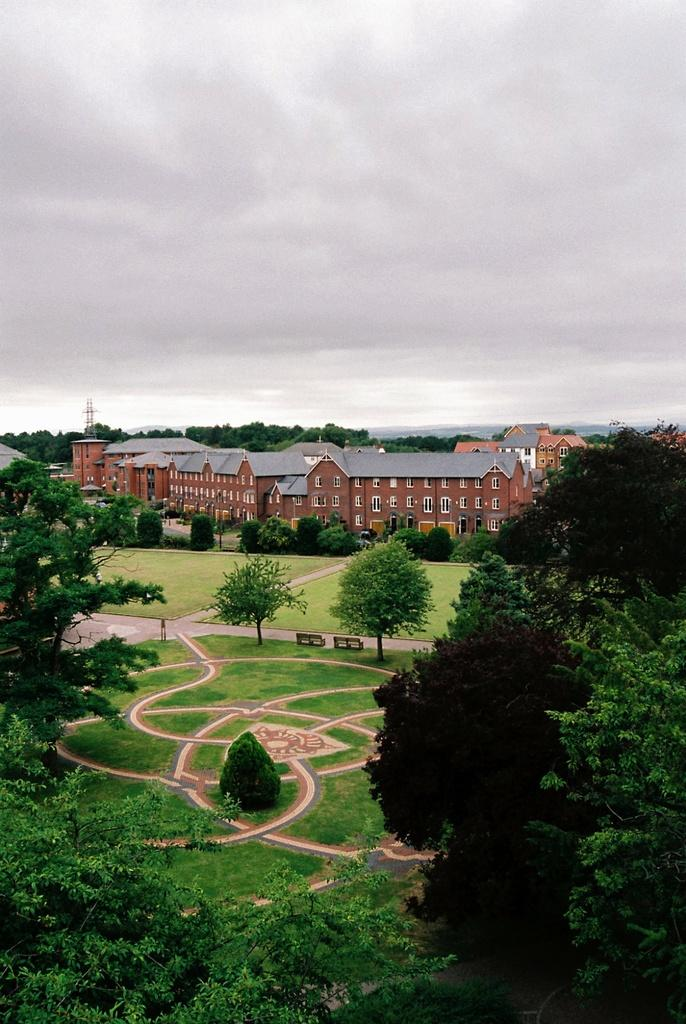What type of structure is visible in the image? There is a building in the image. What feature can be seen on the building? The building has windows. What type of vegetation is present in the image? There are trees in the image. What type of surface can be seen in the image? There is a path in the image. What type of seating is available in the image? There are benches in the image. What type of ground cover is present in the image? Grass is present in the image. What is the condition of the sky in the image? The sky is cloudy in the image. How many strings can be seen attached to the trees in the image? There are no strings visible in the image; only trees, a building, a path, benches, grass, and a cloudy sky are present. 